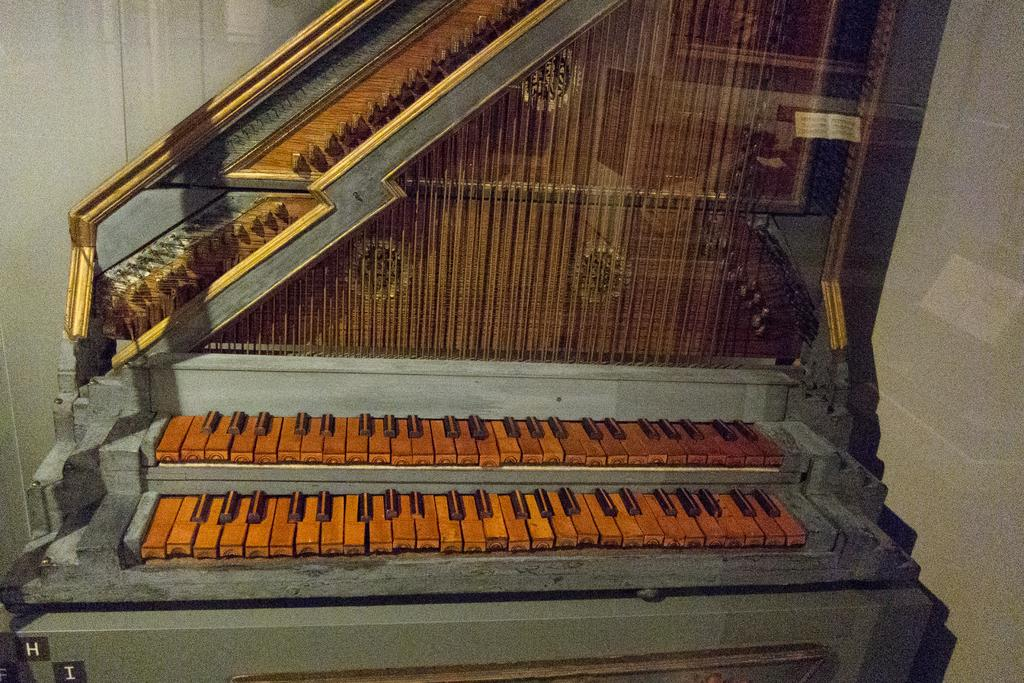What musical instrument is present in the image? There is a piano in the image. What type of sound does the piano typically produce? The piano typically produces a range of musical notes and tones. Is the piano being played in the image? The image does not show whether the piano is being played or not. What might someone need to play the piano in the image? Someone might need sheet music or knowledge of piano keys to play the piano in the image. What direction does the sun move in the image? There is no sun present in the image, as it only features a piano. 